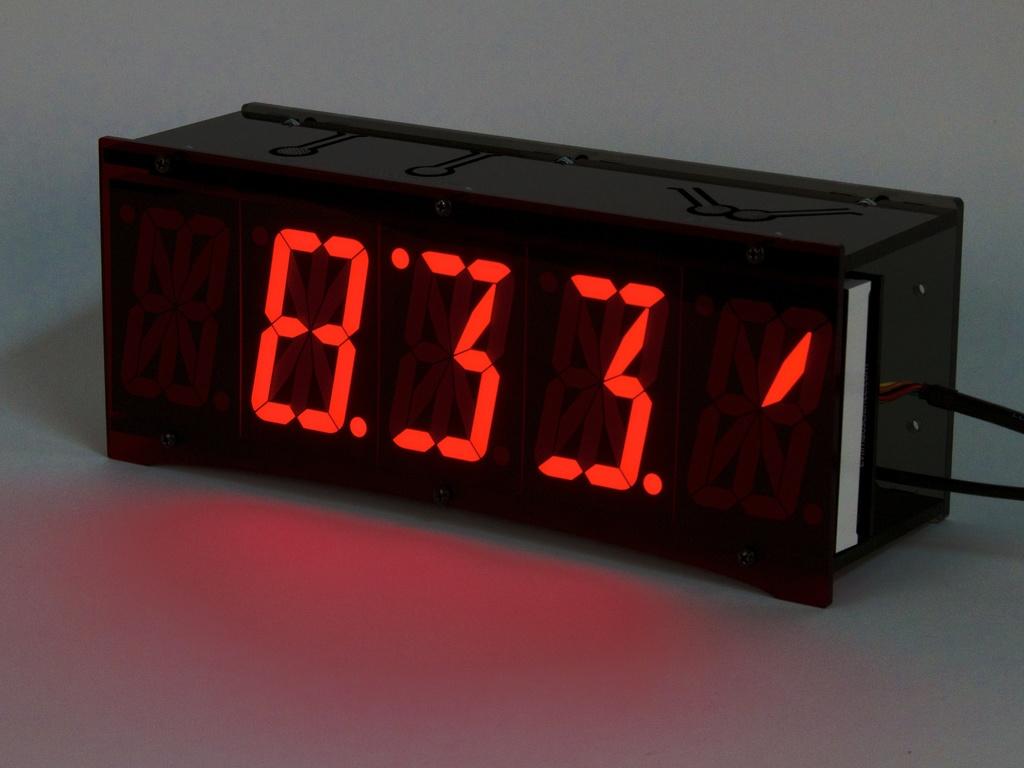What does the clock say?
Your answer should be compact. 8:33. 